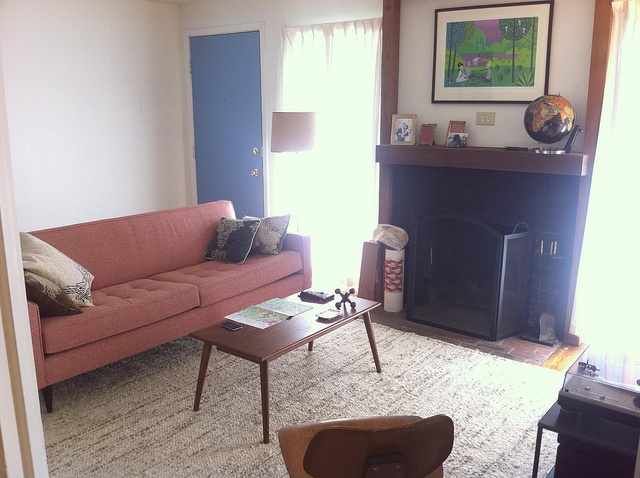Describe the objects in this image and their specific colors. I can see couch in darkgray, brown, and lightgray tones, chair in darkgray, black, maroon, and brown tones, and cell phone in darkgray, black, and gray tones in this image. 